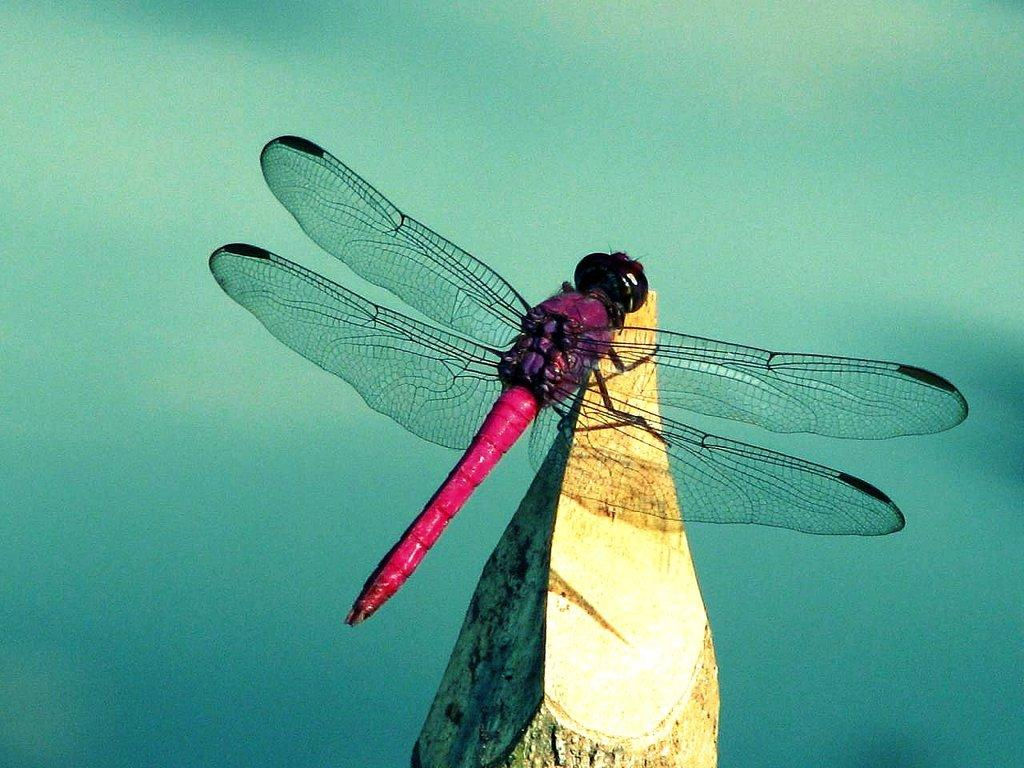What type of creature is in the image? There is an insect in the image. What colors can be seen on the insect? The insect has black, purple, and red colors. Where is the insect located in the image? The insect is on a wooden log. How would you describe the background of the background of the image? The background of the image is blurry. What type of game is being played in the image? There is no game being played in the image; it features an insect on a wooden log. What arithmetic problem is being solved in the image? There is no arithmetic problem being solved in the image; it features an insect on a wooden log. 